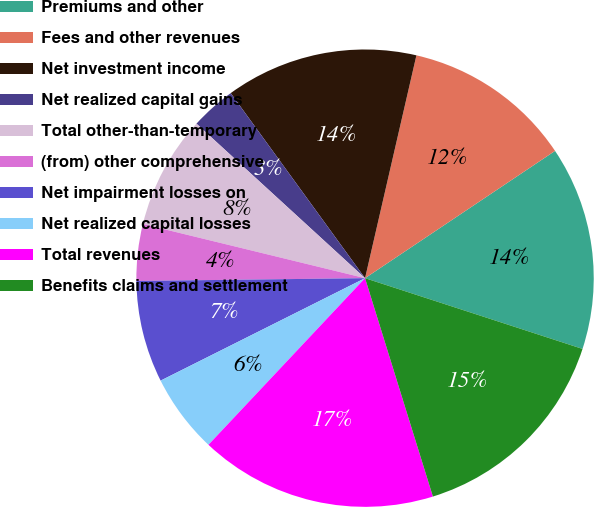Convert chart. <chart><loc_0><loc_0><loc_500><loc_500><pie_chart><fcel>Premiums and other<fcel>Fees and other revenues<fcel>Net investment income<fcel>Net realized capital gains<fcel>Total other-than-temporary<fcel>(from) other comprehensive<fcel>Net impairment losses on<fcel>Net realized capital losses<fcel>Total revenues<fcel>Benefits claims and settlement<nl><fcel>14.4%<fcel>12.0%<fcel>13.6%<fcel>3.2%<fcel>8.0%<fcel>4.0%<fcel>7.2%<fcel>5.6%<fcel>16.8%<fcel>15.2%<nl></chart> 